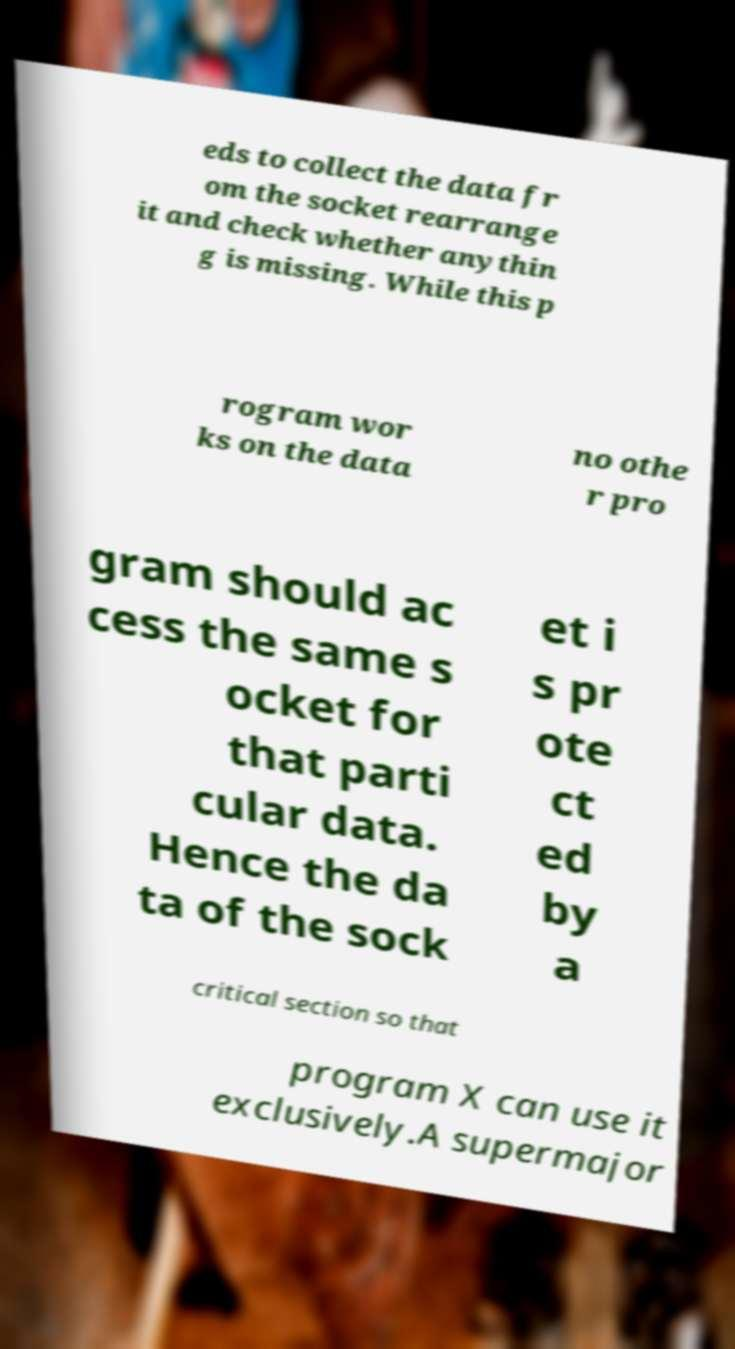What messages or text are displayed in this image? I need them in a readable, typed format. eds to collect the data fr om the socket rearrange it and check whether anythin g is missing. While this p rogram wor ks on the data no othe r pro gram should ac cess the same s ocket for that parti cular data. Hence the da ta of the sock et i s pr ote ct ed by a critical section so that program X can use it exclusively.A supermajor 